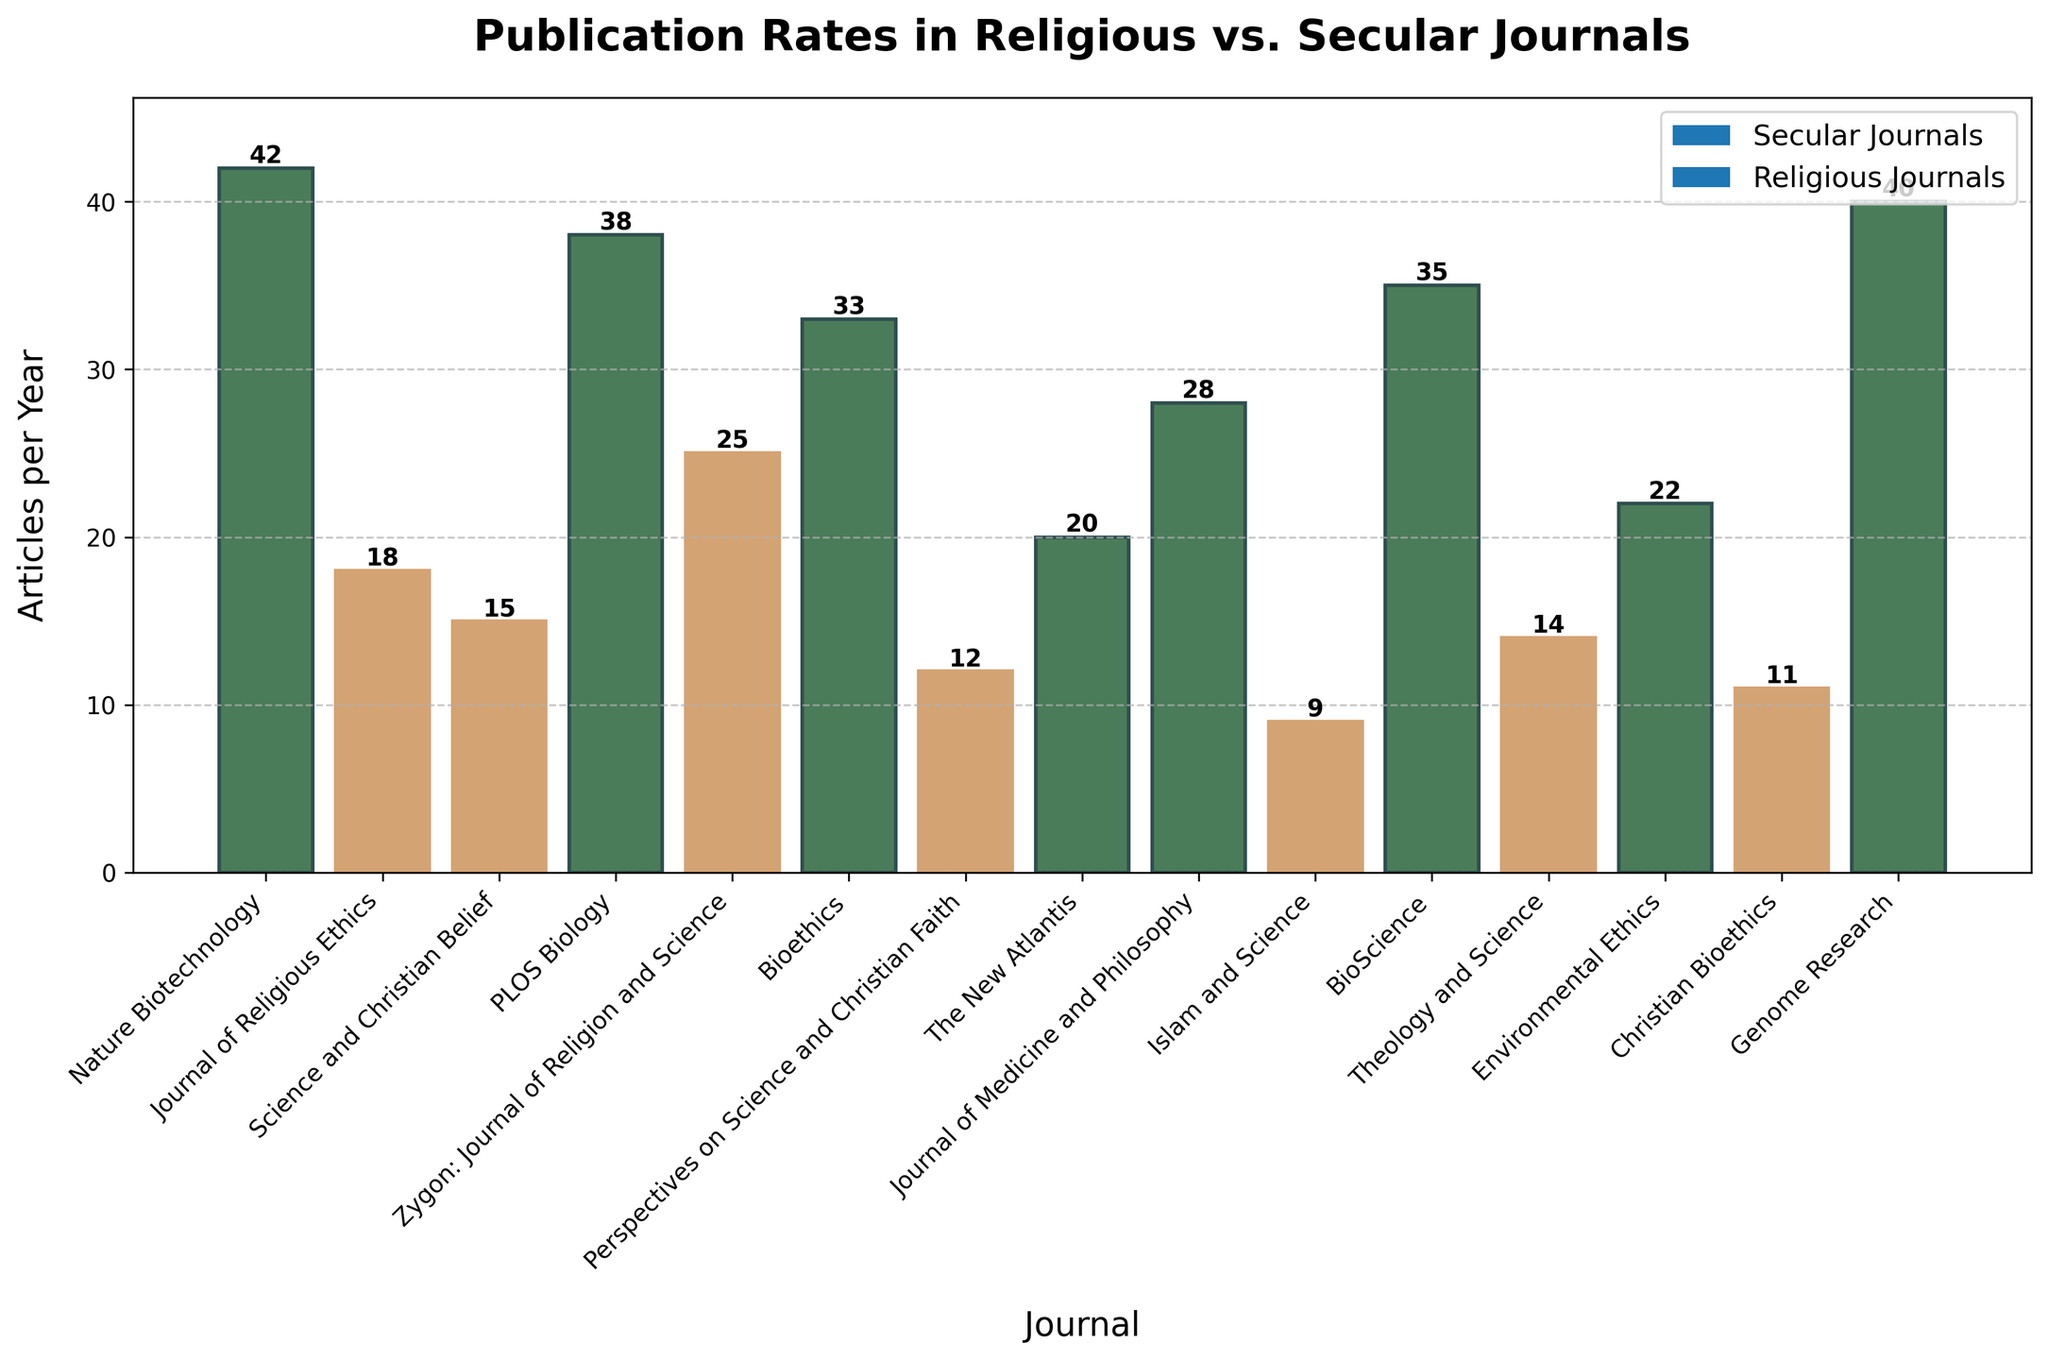What is the publication rate difference between the journal with the highest and the journal with the lowest number of articles per year? To find the difference, identify the journal with the highest number of articles per year (Nature Biotechnology with 42) and the journal with the lowest number (Islam and Science with 9), then subtract the latter from the former: 42 - 9 = 33.
Answer: 33 Which secular journal has the highest publication rate? Review the bar chart to spot the longest green (secular) bar. Nature Biotechnology has the highest rate among the secular journals with 42 articles per year.
Answer: Nature Biotechnology What is the average number of articles published per year in secular journals? First, identify the publication rates in secular journals: 42, 38, 33, 35, 22, 40. Sum these values: 42 + 38 + 33 + 35 + 22 + 40 = 210. Then, divide by the number of journals, which is 6: 210 / 6 = 35.
Answer: 35 Are there more articles published per year in secular journals or religious journals? Sum the publication rates for secular journals (42, 38, 33, 35, 22, 40), which equals 210, and for religious journals (18, 15, 25, 12, 9, 14, 11), which equals 104. Since 210 > 104, secular journals publish more articles.
Answer: Secular journals How many articles per year are published across all religious journals combined? Sum the publication rates for all religious journals: 18 + 15 + 25 + 12 + 9 + 14 + 11 = 104.
Answer: 104 Which journal has the highest number of published articles with an ethical focus on genetic engineering? Look for the tallest bar in the chart. Nature Biotechnology stands out with the highest number of articles per year at 42.
Answer: Nature Biotechnology How many articles per year are published in journals with "Science" in their title? Sum the publication rates for journals whose titles include "Science": Science and Christian Belief (15), PLOS Biology (38), Zygon: Journal of Religion and Science (25), BioScience (35), Theology and Science (14). 15 + 38 + 25 + 35 + 14 = 127.
Answer: 127 Which religious journal publishes the fewest articles per year? Identify the shortest bar among the religious journals. Islam and Science has the fewest articles per year at 9.
Answer: Islam and Science What is the average number of articles per year in all journals combined? Sum publication rates of all journals: 42 + 18 + 15 + 38 + 25 + 33 + 12 + 20 + 28 + 9 + 35 + 14 + 22 + 11 + 40 = 362. Then, divide by the total number of journals, which is 15: 362 / 15 ≈ 24.13.
Answer: 24.13 